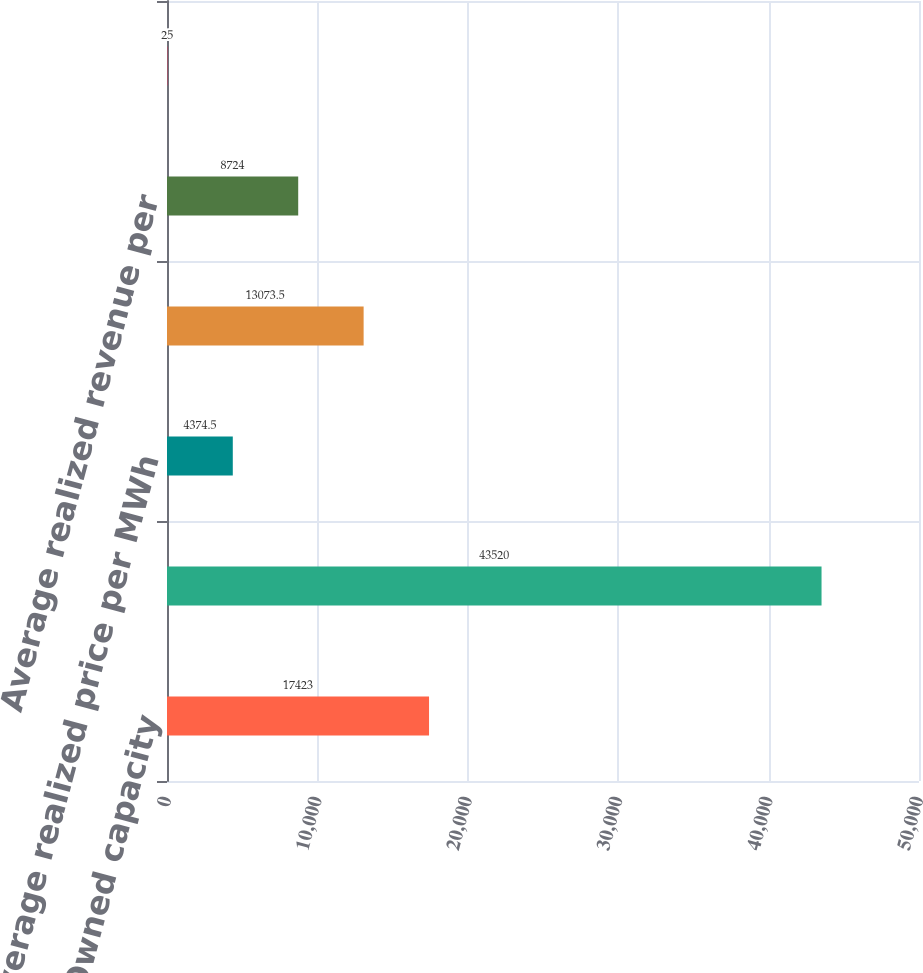Convert chart. <chart><loc_0><loc_0><loc_500><loc_500><bar_chart><fcel>Owned capacity<fcel>GWh billed<fcel>Average realized price per MWh<fcel>Capacity factor<fcel>Average realized revenue per<fcel>Vermont Yankee<nl><fcel>17423<fcel>43520<fcel>4374.5<fcel>13073.5<fcel>8724<fcel>25<nl></chart> 